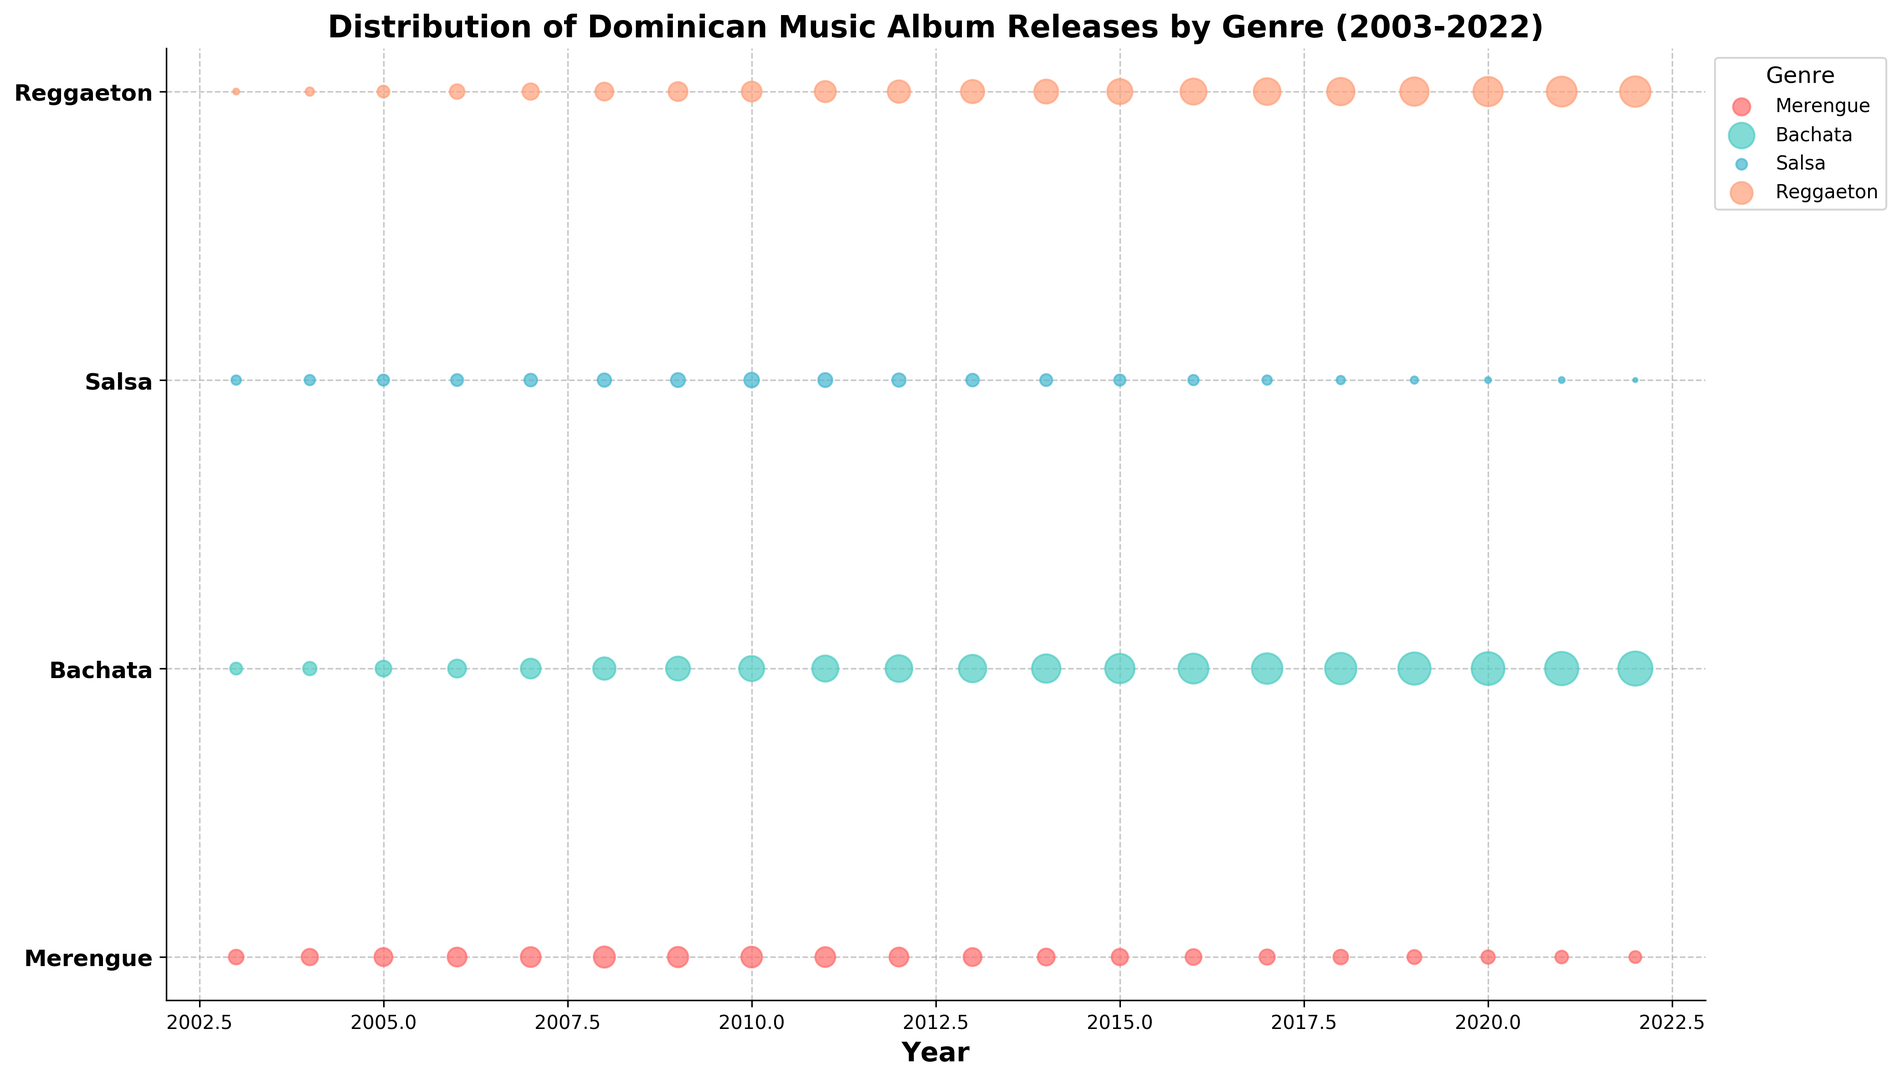What's the overall trend of album releases for the genre Bachata from 2003 to 2022? From the plot, we observe that the size of the bubbles representing Bachata album releases consistently increases each year. This indicates that the number of Bachata albums released has been steadily growing over the 20 years.
Answer: Growing Comparing 2003 and 2022, which genre saw the largest increase in album releases? To determine this, we need to compare the size of the bubbles for each genre in 2003 and 2022. Bachata had 8 releases in 2003 and 65 in 2022, an increase of 57 albums. Reggaeton had the second-largest increase from 2 in 2003 to 52 in 2022, resulting in an increase of 50 albums. Thus, Bachata saw the largest increase.
Answer: Bachata In what year did Merengue album releases start to decline? Looking at the plot, Merengue album releases peaked around 2008 and then began to decrease. By 2009, the bubbles representing Merengue album releases get smaller, indicating a decline.
Answer: 2009 What's the difference in the number of Salsa album releases between the year with the most releases and the year with the fewest releases? From the plot, the maximum number of Salsa albums was released in 2010 and 2011 with 12 albums each, and the minimum in 2022 with 1 album. The difference is thus 12 - 1.
Answer: 11 Which genre showed the greatest variability in releases over the 20-year period? Variability can be inferred by the range in the size of the bubbles over the years for each genre. Bachata shows the greatest variability with the size of the bubbles going from 8 in 2003 to 65 in 2022, showing a wide range and thus high variability.
Answer: Bachata How do Reggaeton album releases in 2008 compare to the releases in 2018? From the plot, Reggaeton had 18 album releases in 2008 and 42 in 2018. Comparing the sizes of the bubbles, it is evident that releases more than doubled over this decade.
Answer: More than doubled What can be inferred about the popularity of Salsa over the years? By observing the plot, the bubble size for Salsa releases remains relatively consistent but starts to shrink significantly after 2010, indicating fewer releases and suggesting a decline in popularity.
Answer: Declining Was there any year where the Merengue album releases equaled the Salsa album releases? Visual comparison of the bubbles shows that in 2015, both Merengue and Salsa released 15 and 7 albums, respectively, not equal. However, in 2021, Merengue had 9 releases and Salsa had 2, which are also not equal in any year shown.
Answer: No In which year did all genres, except Salsa, see an increase in the number of album releases? Observing the bubbles, in 2006, all genres (Merengue, Bachata, and Reggaeton) saw an increase in their respective bubble sizes compared to 2005, while Salsa did not show an increase across these years.
Answer: 2006 How does the number of Bachata albums released in 2022 compare to the number of Reggaeton albums released in 2012? From the plot, Bachata had 65 album releases in 2022 and Reggaeton had 28 in 2012. The sizes of the bubbles show that Bachata releases in 2022 were significantly higher than Reggaeton releases in 2012.
Answer: Higher 